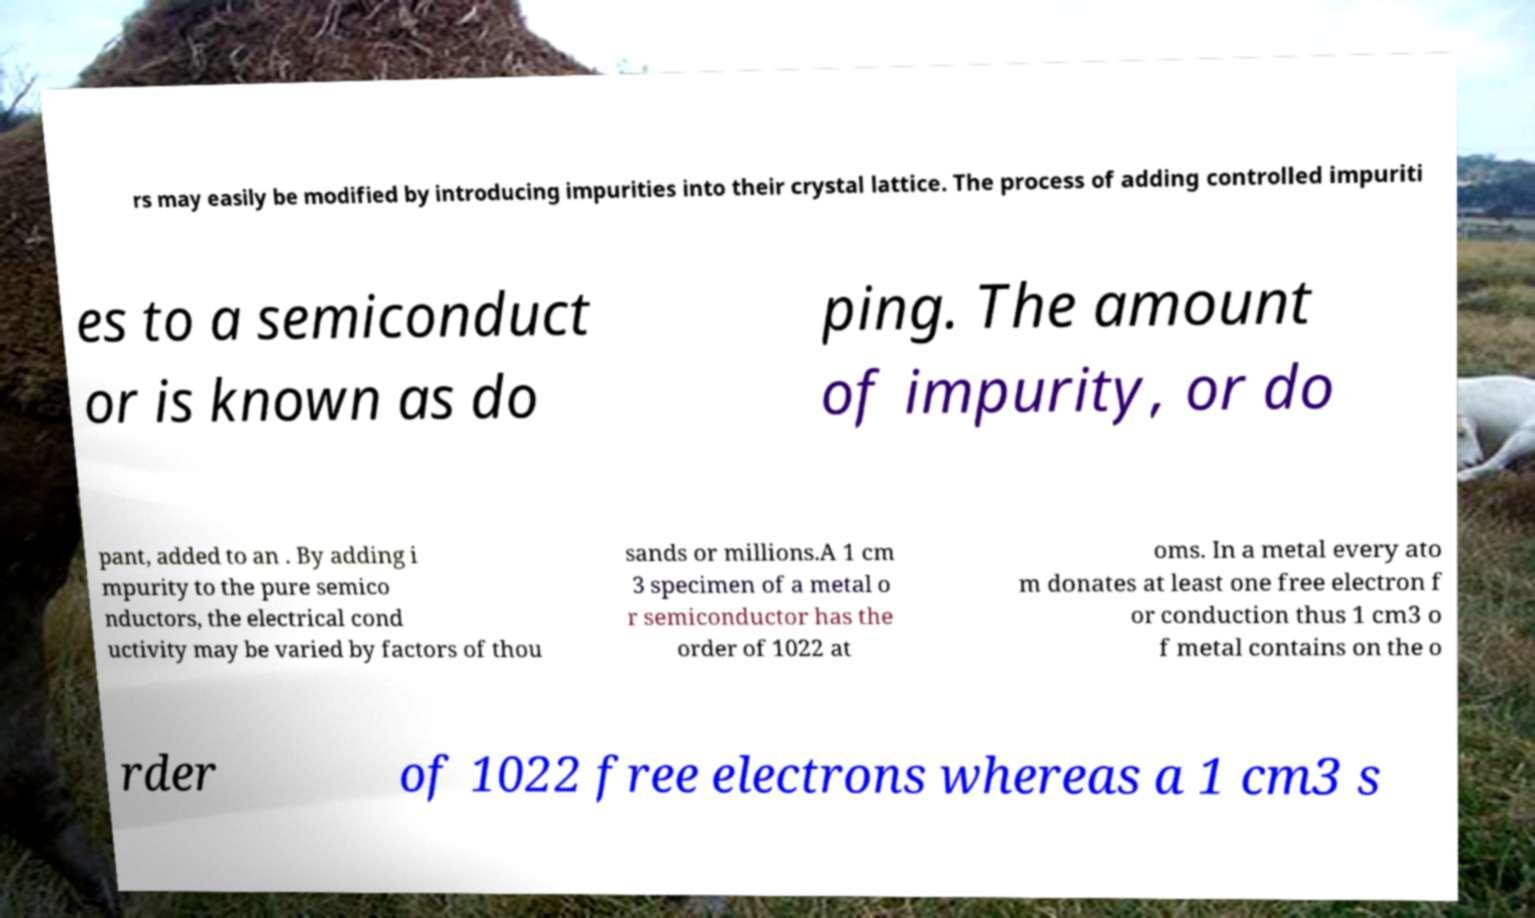Please identify and transcribe the text found in this image. rs may easily be modified by introducing impurities into their crystal lattice. The process of adding controlled impuriti es to a semiconduct or is known as do ping. The amount of impurity, or do pant, added to an . By adding i mpurity to the pure semico nductors, the electrical cond uctivity may be varied by factors of thou sands or millions.A 1 cm 3 specimen of a metal o r semiconductor has the order of 1022 at oms. In a metal every ato m donates at least one free electron f or conduction thus 1 cm3 o f metal contains on the o rder of 1022 free electrons whereas a 1 cm3 s 